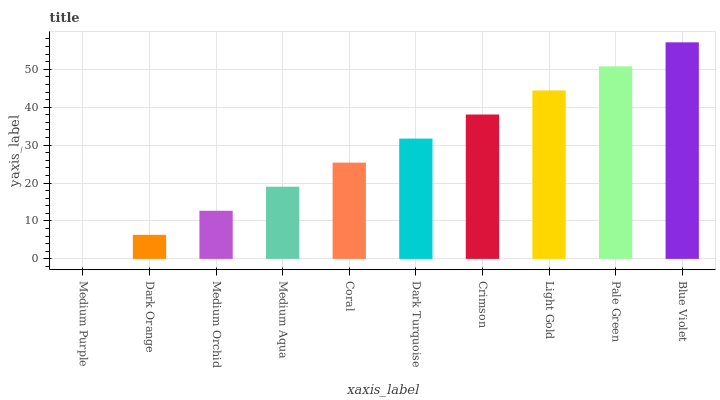Is Medium Purple the minimum?
Answer yes or no. Yes. Is Blue Violet the maximum?
Answer yes or no. Yes. Is Dark Orange the minimum?
Answer yes or no. No. Is Dark Orange the maximum?
Answer yes or no. No. Is Dark Orange greater than Medium Purple?
Answer yes or no. Yes. Is Medium Purple less than Dark Orange?
Answer yes or no. Yes. Is Medium Purple greater than Dark Orange?
Answer yes or no. No. Is Dark Orange less than Medium Purple?
Answer yes or no. No. Is Dark Turquoise the high median?
Answer yes or no. Yes. Is Coral the low median?
Answer yes or no. Yes. Is Medium Orchid the high median?
Answer yes or no. No. Is Medium Purple the low median?
Answer yes or no. No. 